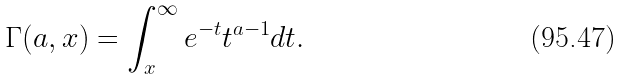Convert formula to latex. <formula><loc_0><loc_0><loc_500><loc_500>\Gamma ( a , x ) = \int _ { x } ^ { \infty } e ^ { - t } t ^ { a - 1 } d t .</formula> 